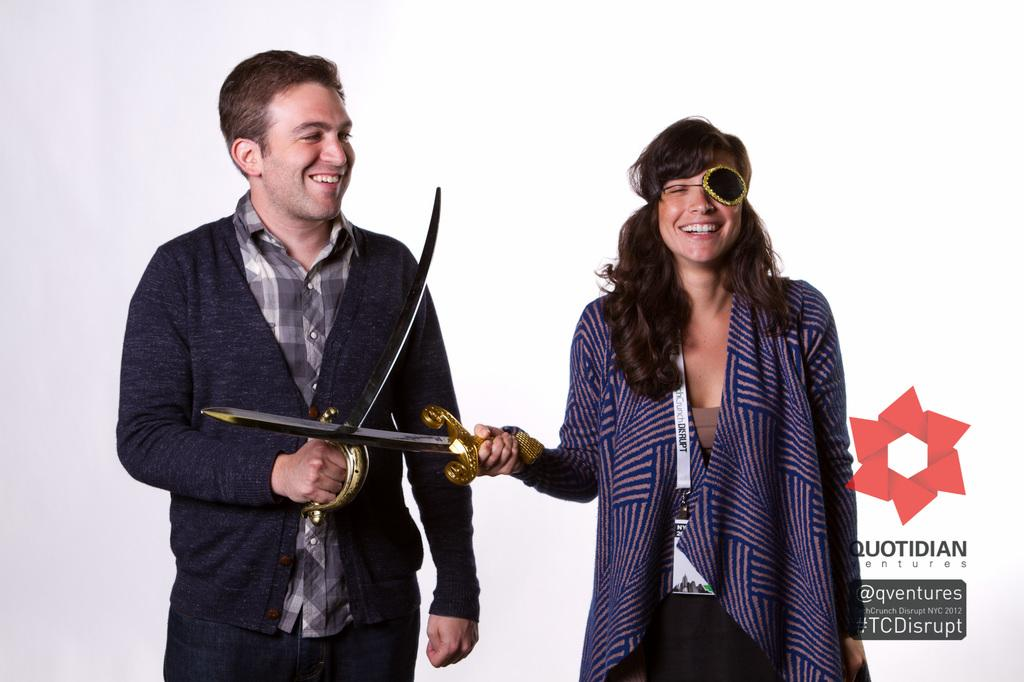Who or what is present in the image? There are people in the image. What are the people doing in the image? The people are standing and smiling. What objects are the people holding in the image? The people are holding swords. Is there any text or logo in the image? Yes, there is text and a logo in the bottom right side of the image. What type of ring can be seen on the people's fingers in the image? There are no rings visible on the people's fingers in the image. What is the love interest of the people in the image? There is no indication of a love interest in the image; the people are simply standing and smiling while holding swords. 